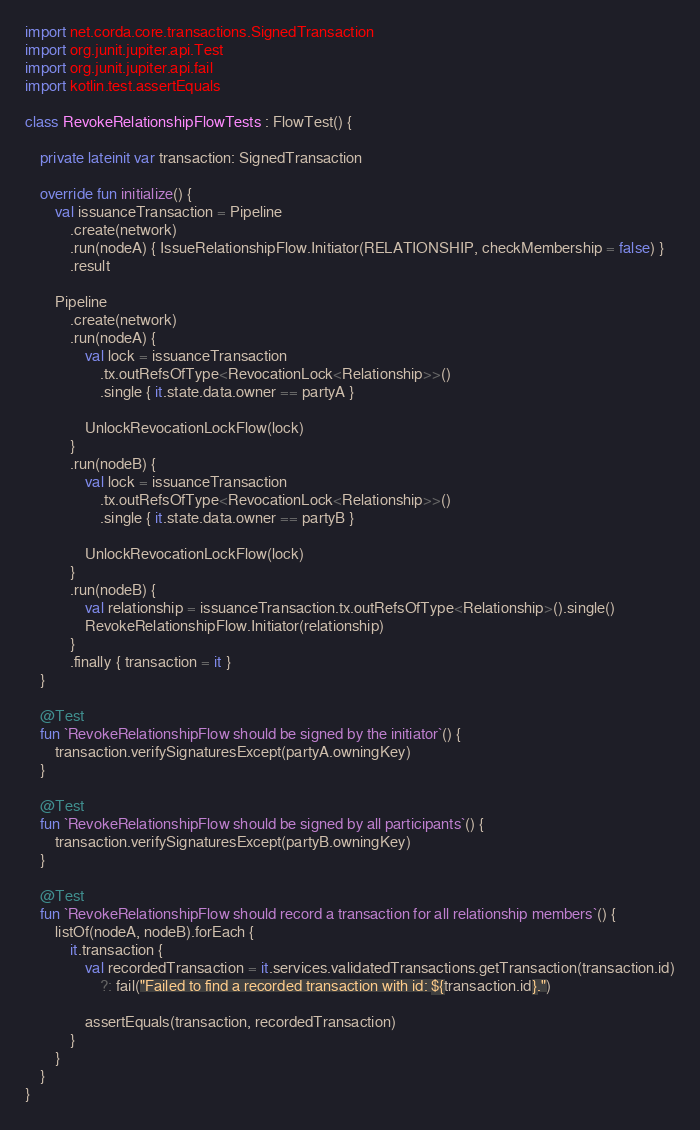Convert code to text. <code><loc_0><loc_0><loc_500><loc_500><_Kotlin_>import net.corda.core.transactions.SignedTransaction
import org.junit.jupiter.api.Test
import org.junit.jupiter.api.fail
import kotlin.test.assertEquals

class RevokeRelationshipFlowTests : FlowTest() {

    private lateinit var transaction: SignedTransaction

    override fun initialize() {
        val issuanceTransaction = Pipeline
            .create(network)
            .run(nodeA) { IssueRelationshipFlow.Initiator(RELATIONSHIP, checkMembership = false) }
            .result

        Pipeline
            .create(network)
            .run(nodeA) {
                val lock = issuanceTransaction
                    .tx.outRefsOfType<RevocationLock<Relationship>>()
                    .single { it.state.data.owner == partyA }

                UnlockRevocationLockFlow(lock)
            }
            .run(nodeB) {
                val lock = issuanceTransaction
                    .tx.outRefsOfType<RevocationLock<Relationship>>()
                    .single { it.state.data.owner == partyB }

                UnlockRevocationLockFlow(lock)
            }
            .run(nodeB) {
                val relationship = issuanceTransaction.tx.outRefsOfType<Relationship>().single()
                RevokeRelationshipFlow.Initiator(relationship)
            }
            .finally { transaction = it }
    }

    @Test
    fun `RevokeRelationshipFlow should be signed by the initiator`() {
        transaction.verifySignaturesExcept(partyA.owningKey)
    }

    @Test
    fun `RevokeRelationshipFlow should be signed by all participants`() {
        transaction.verifySignaturesExcept(partyB.owningKey)
    }

    @Test
    fun `RevokeRelationshipFlow should record a transaction for all relationship members`() {
        listOf(nodeA, nodeB).forEach {
            it.transaction {
                val recordedTransaction = it.services.validatedTransactions.getTransaction(transaction.id)
                    ?: fail("Failed to find a recorded transaction with id: ${transaction.id}.")

                assertEquals(transaction, recordedTransaction)
            }
        }
    }
}
</code> 